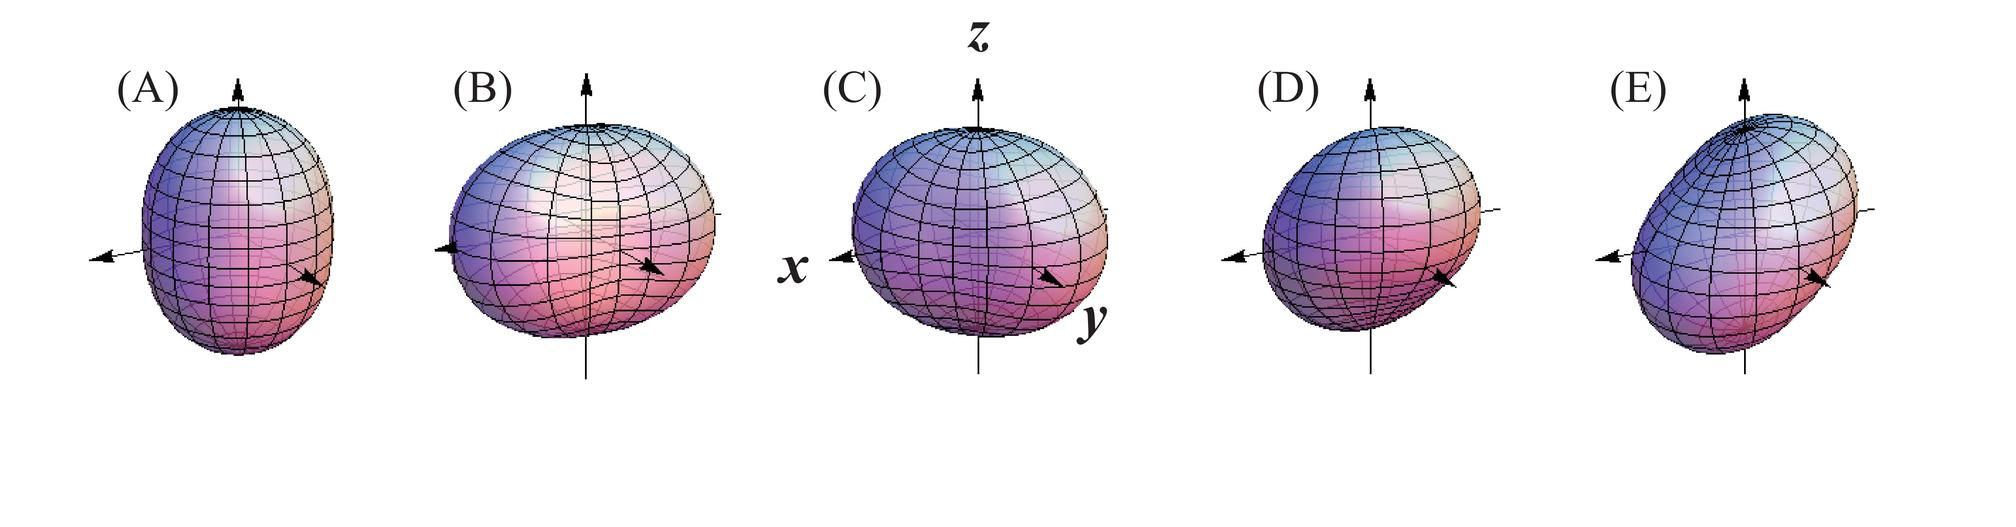What physical property is primarily being demonstrated in these sequences of figures? A) Heat distribution across a surface B) Magnetic field lines around a bar magnet C) Stress distribution within a material under load D) Deformation of a spherical object under different forces The sequence of figures visually illustrates the concept of deformation, where a spherical object is displayed under various conditions of force and pressure, evidenced through changes in its shape. The arrows signify the direction and relative magnitude of applied pressures or forces, which results in the object's distortion from its original shape. This is a typical representation used in physics and engineering to demonstrate how solid bodies react to external stresses, reinforcing the concept that the correct answer is D) Deformation of a spherical object under different forces. 